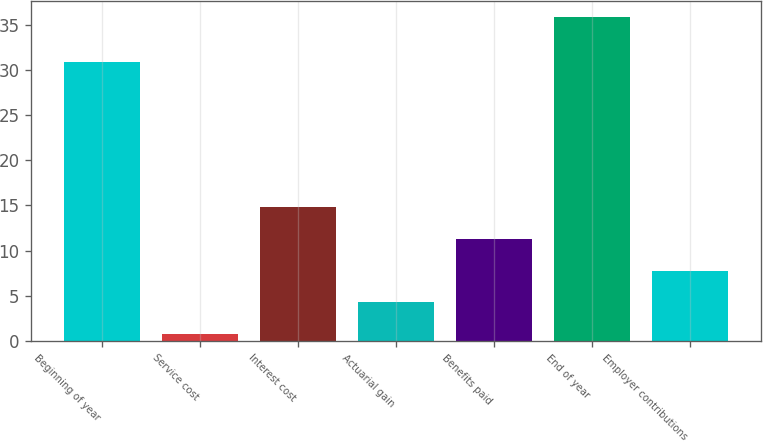Convert chart to OTSL. <chart><loc_0><loc_0><loc_500><loc_500><bar_chart><fcel>Beginning of year<fcel>Service cost<fcel>Interest cost<fcel>Actuarial gain<fcel>Benefits paid<fcel>End of year<fcel>Employer contributions<nl><fcel>30.9<fcel>0.8<fcel>14.8<fcel>4.3<fcel>11.3<fcel>35.8<fcel>7.8<nl></chart> 